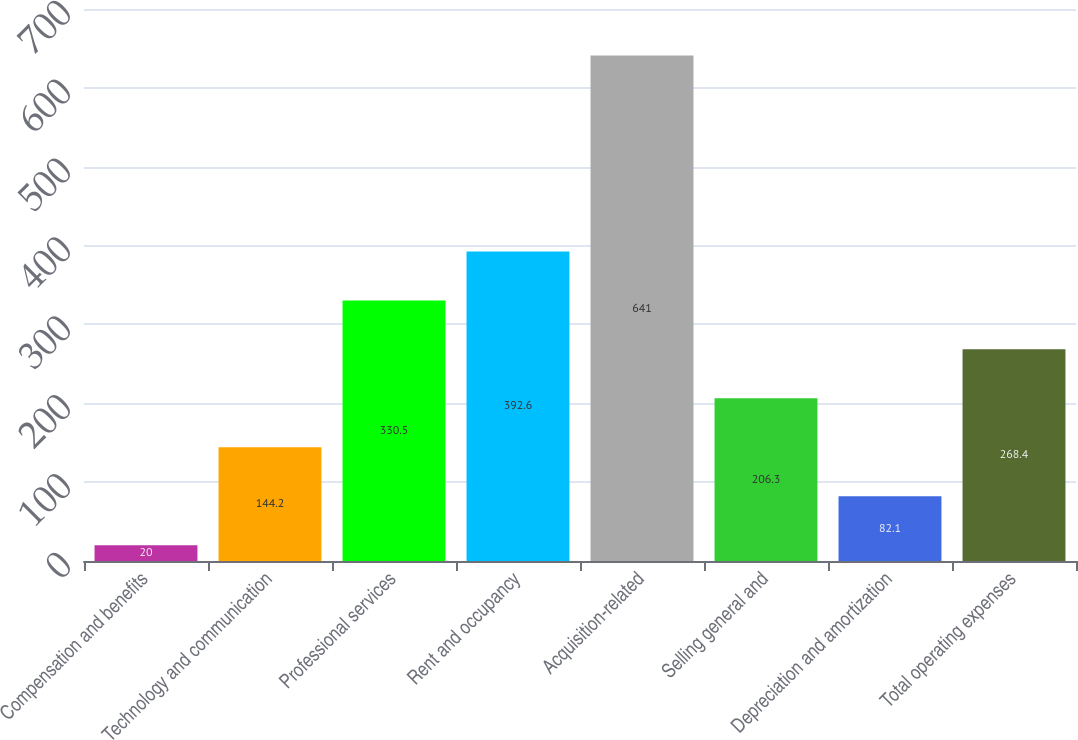<chart> <loc_0><loc_0><loc_500><loc_500><bar_chart><fcel>Compensation and benefits<fcel>Technology and communication<fcel>Professional services<fcel>Rent and occupancy<fcel>Acquisition-related<fcel>Selling general and<fcel>Depreciation and amortization<fcel>Total operating expenses<nl><fcel>20<fcel>144.2<fcel>330.5<fcel>392.6<fcel>641<fcel>206.3<fcel>82.1<fcel>268.4<nl></chart> 